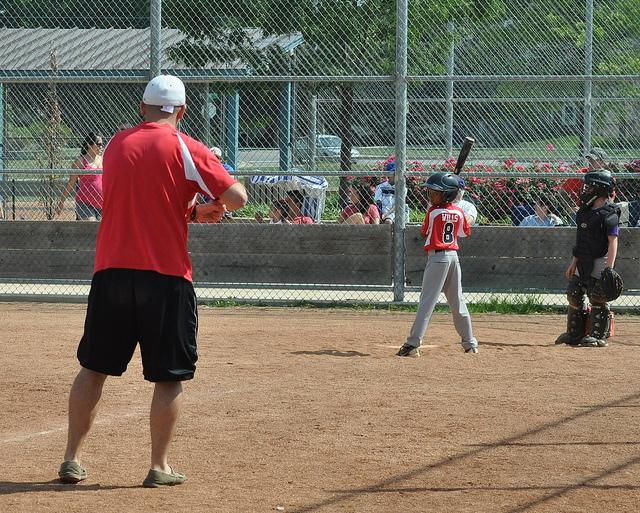What type of field are the kids playing on? Please explain your reasoning. softball. The kids are playing a batting game and need a certain type of field. 